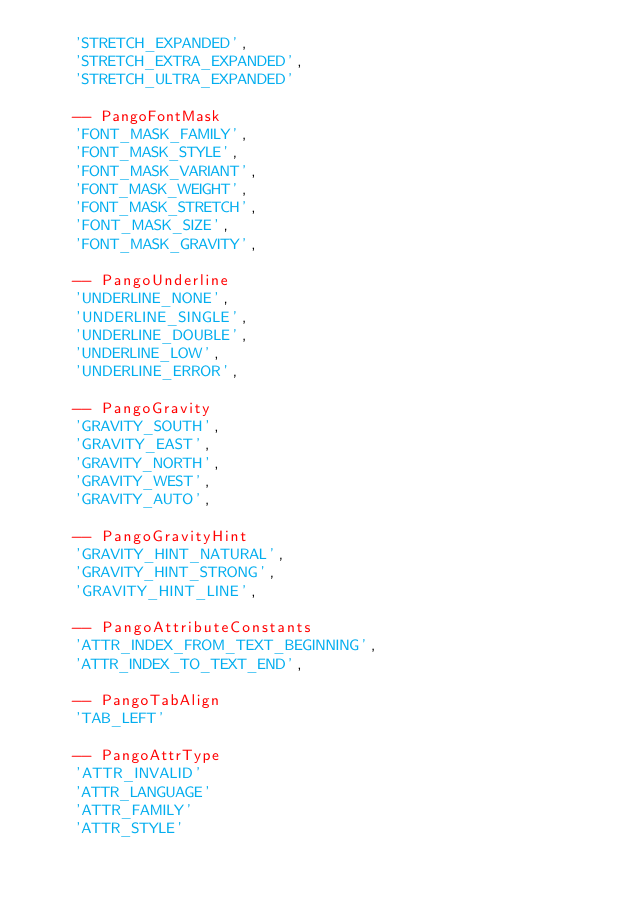<code> <loc_0><loc_0><loc_500><loc_500><_MoonScript_>    'STRETCH_EXPANDED',
    'STRETCH_EXTRA_EXPANDED',
    'STRETCH_ULTRA_EXPANDED'

    -- PangoFontMask
    'FONT_MASK_FAMILY',
    'FONT_MASK_STYLE',
    'FONT_MASK_VARIANT',
    'FONT_MASK_WEIGHT',
    'FONT_MASK_STRETCH',
    'FONT_MASK_SIZE',
    'FONT_MASK_GRAVITY',

    -- PangoUnderline
    'UNDERLINE_NONE',
    'UNDERLINE_SINGLE',
    'UNDERLINE_DOUBLE',
    'UNDERLINE_LOW',
    'UNDERLINE_ERROR',

    -- PangoGravity
    'GRAVITY_SOUTH',
    'GRAVITY_EAST',
    'GRAVITY_NORTH',
    'GRAVITY_WEST',
    'GRAVITY_AUTO',

    -- PangoGravityHint
    'GRAVITY_HINT_NATURAL',
    'GRAVITY_HINT_STRONG',
    'GRAVITY_HINT_LINE',

    -- PangoAttributeConstants
    'ATTR_INDEX_FROM_TEXT_BEGINNING',
    'ATTR_INDEX_TO_TEXT_END',

    -- PangoTabAlign
    'TAB_LEFT'

    -- PangoAttrType
    'ATTR_INVALID'
    'ATTR_LANGUAGE'
    'ATTR_FAMILY'
    'ATTR_STYLE'</code> 